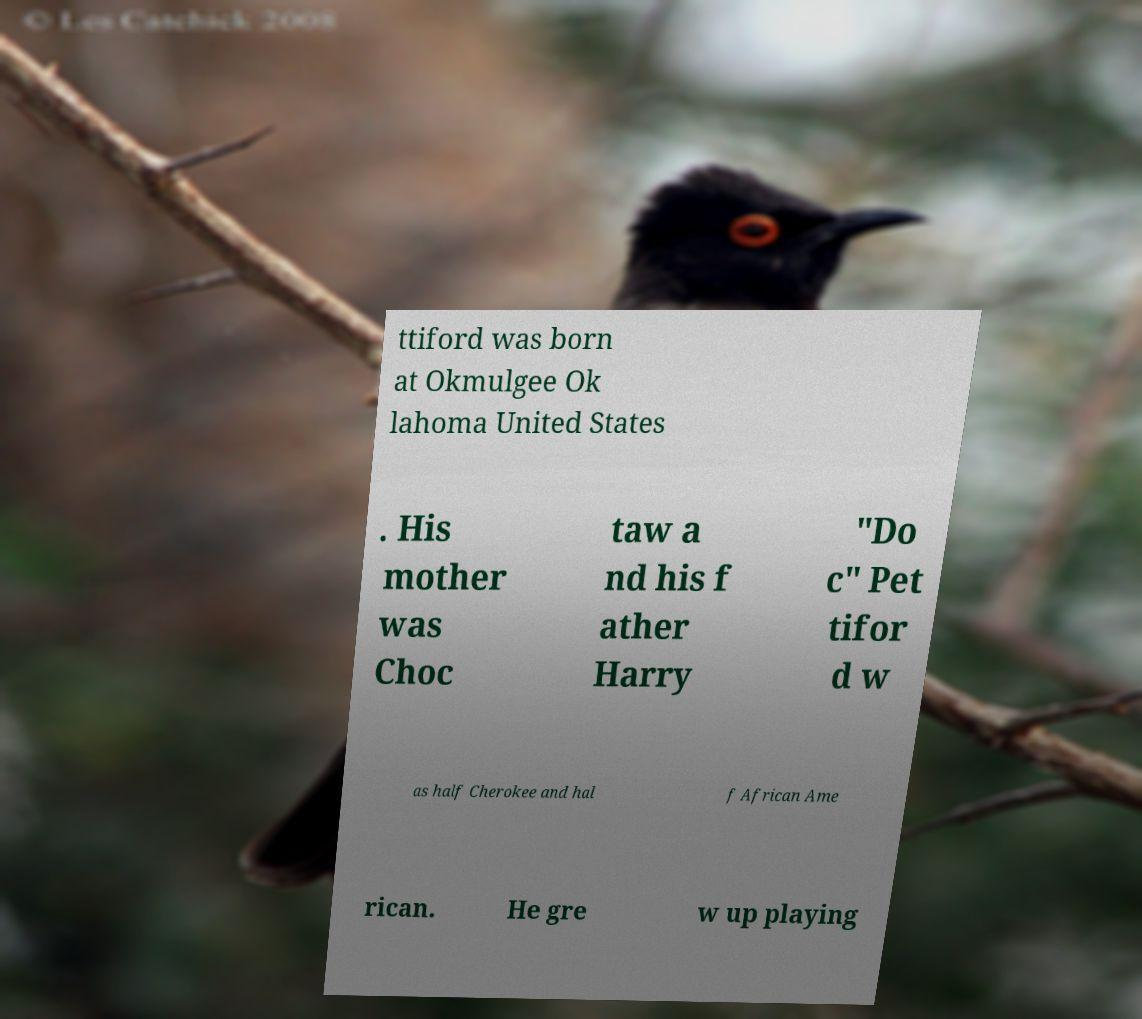Can you accurately transcribe the text from the provided image for me? ttiford was born at Okmulgee Ok lahoma United States . His mother was Choc taw a nd his f ather Harry "Do c" Pet tifor d w as half Cherokee and hal f African Ame rican. He gre w up playing 